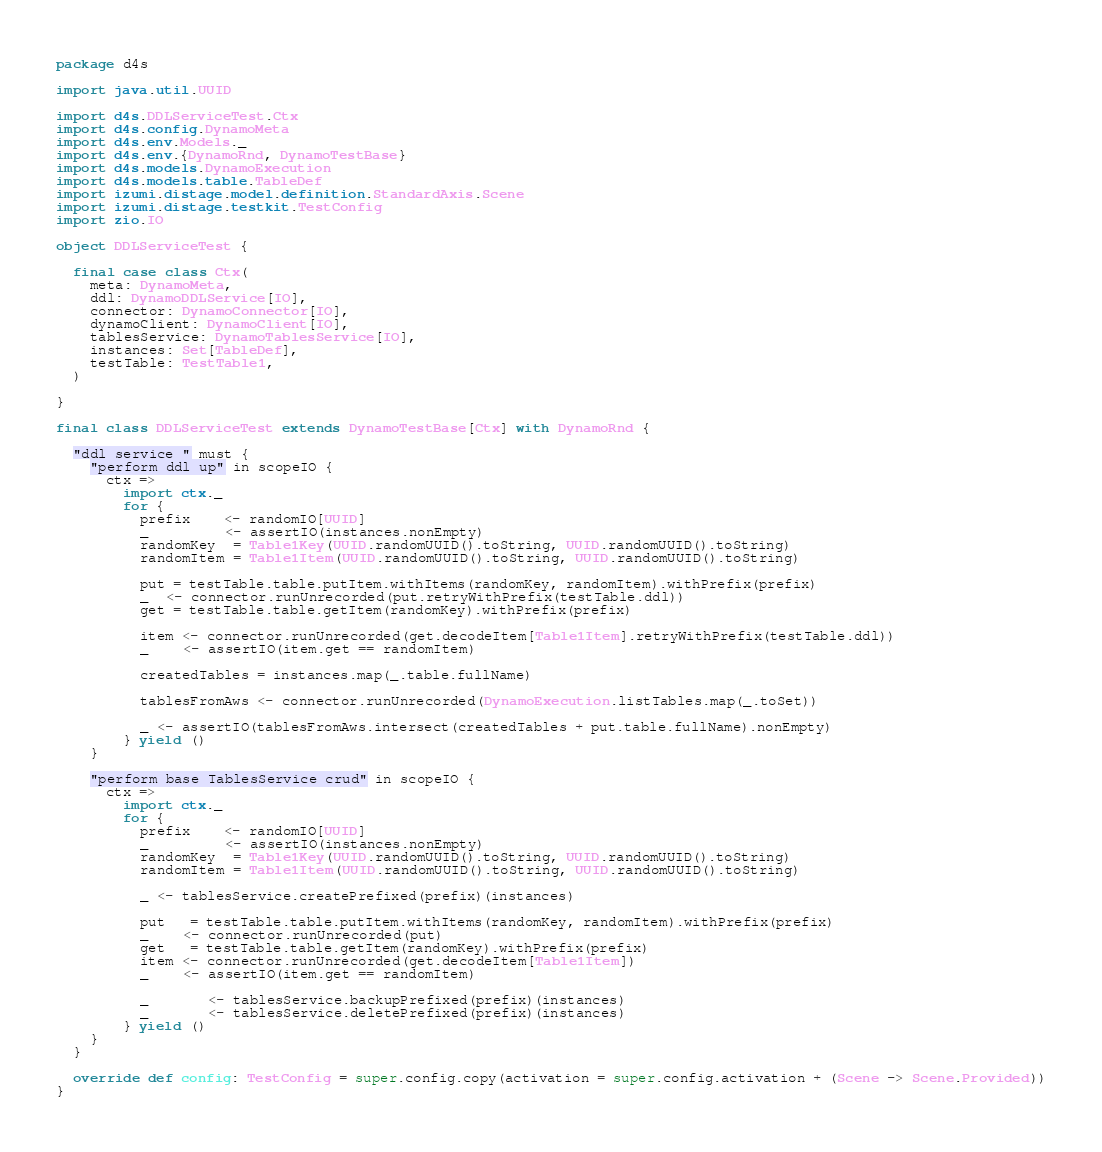Convert code to text. <code><loc_0><loc_0><loc_500><loc_500><_Scala_>package d4s

import java.util.UUID

import d4s.DDLServiceTest.Ctx
import d4s.config.DynamoMeta
import d4s.env.Models._
import d4s.env.{DynamoRnd, DynamoTestBase}
import d4s.models.DynamoExecution
import d4s.models.table.TableDef
import izumi.distage.model.definition.StandardAxis.Scene
import izumi.distage.testkit.TestConfig
import zio.IO

object DDLServiceTest {

  final case class Ctx(
    meta: DynamoMeta,
    ddl: DynamoDDLService[IO],
    connector: DynamoConnector[IO],
    dynamoClient: DynamoClient[IO],
    tablesService: DynamoTablesService[IO],
    instances: Set[TableDef],
    testTable: TestTable1,
  )

}

final class DDLServiceTest extends DynamoTestBase[Ctx] with DynamoRnd {

  "ddl service " must {
    "perform ddl up" in scopeIO {
      ctx =>
        import ctx._
        for {
          prefix    <- randomIO[UUID]
          _         <- assertIO(instances.nonEmpty)
          randomKey  = Table1Key(UUID.randomUUID().toString, UUID.randomUUID().toString)
          randomItem = Table1Item(UUID.randomUUID().toString, UUID.randomUUID().toString)

          put = testTable.table.putItem.withItems(randomKey, randomItem).withPrefix(prefix)
          _  <- connector.runUnrecorded(put.retryWithPrefix(testTable.ddl))
          get = testTable.table.getItem(randomKey).withPrefix(prefix)

          item <- connector.runUnrecorded(get.decodeItem[Table1Item].retryWithPrefix(testTable.ddl))
          _    <- assertIO(item.get == randomItem)

          createdTables = instances.map(_.table.fullName)

          tablesFromAws <- connector.runUnrecorded(DynamoExecution.listTables.map(_.toSet))

          _ <- assertIO(tablesFromAws.intersect(createdTables + put.table.fullName).nonEmpty)
        } yield ()
    }

    "perform base TablesService crud" in scopeIO {
      ctx =>
        import ctx._
        for {
          prefix    <- randomIO[UUID]
          _         <- assertIO(instances.nonEmpty)
          randomKey  = Table1Key(UUID.randomUUID().toString, UUID.randomUUID().toString)
          randomItem = Table1Item(UUID.randomUUID().toString, UUID.randomUUID().toString)

          _ <- tablesService.createPrefixed(prefix)(instances)

          put   = testTable.table.putItem.withItems(randomKey, randomItem).withPrefix(prefix)
          _    <- connector.runUnrecorded(put)
          get   = testTable.table.getItem(randomKey).withPrefix(prefix)
          item <- connector.runUnrecorded(get.decodeItem[Table1Item])
          _    <- assertIO(item.get == randomItem)

          _       <- tablesService.backupPrefixed(prefix)(instances)
          _       <- tablesService.deletePrefixed(prefix)(instances)
        } yield ()
    }
  }

  override def config: TestConfig = super.config.copy(activation = super.config.activation + (Scene -> Scene.Provided))
}
</code> 